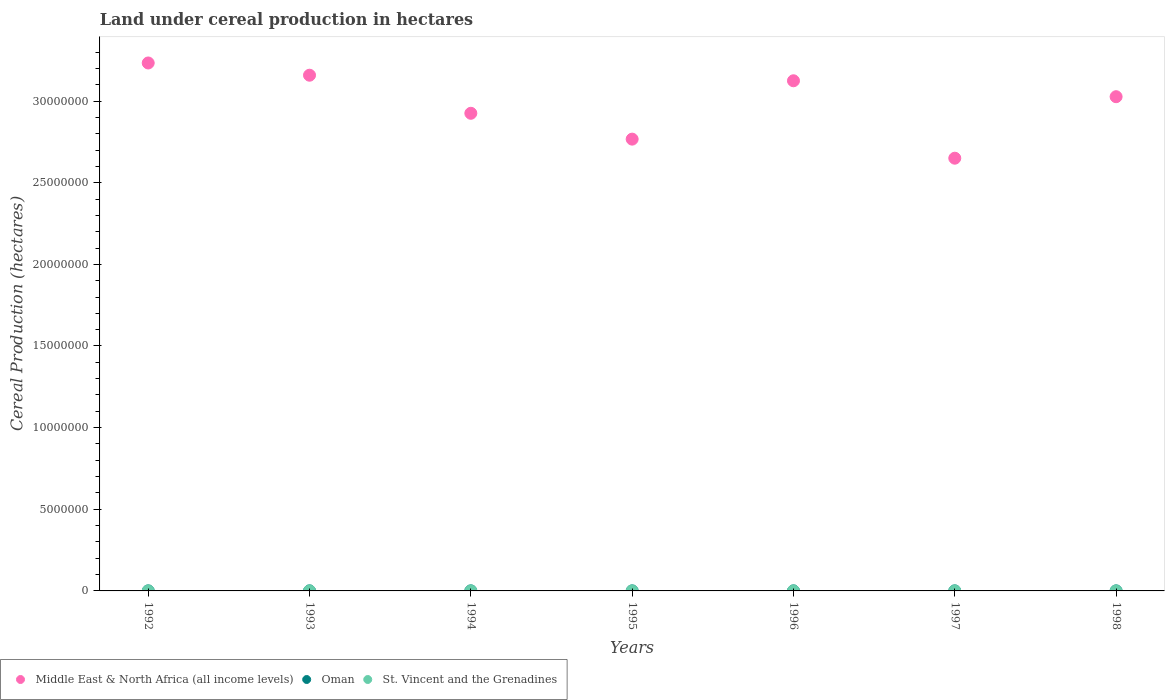Is the number of dotlines equal to the number of legend labels?
Keep it short and to the point. Yes. What is the land under cereal production in Oman in 1992?
Make the answer very short. 2814. Across all years, what is the maximum land under cereal production in Middle East & North Africa (all income levels)?
Provide a short and direct response. 3.23e+07. Across all years, what is the minimum land under cereal production in Middle East & North Africa (all income levels)?
Provide a succinct answer. 2.65e+07. What is the total land under cereal production in Oman in the graph?
Make the answer very short. 2.19e+04. What is the difference between the land under cereal production in Middle East & North Africa (all income levels) in 1993 and that in 1995?
Keep it short and to the point. 3.91e+06. What is the difference between the land under cereal production in Middle East & North Africa (all income levels) in 1998 and the land under cereal production in Oman in 1997?
Make the answer very short. 3.03e+07. What is the average land under cereal production in Oman per year?
Give a very brief answer. 3135.57. In the year 1997, what is the difference between the land under cereal production in St. Vincent and the Grenadines and land under cereal production in Oman?
Make the answer very short. -2891. In how many years, is the land under cereal production in Middle East & North Africa (all income levels) greater than 16000000 hectares?
Offer a terse response. 7. What is the ratio of the land under cereal production in Oman in 1995 to that in 1998?
Make the answer very short. 1.03. Is the land under cereal production in St. Vincent and the Grenadines in 1994 less than that in 1995?
Your answer should be very brief. Yes. Is the difference between the land under cereal production in St. Vincent and the Grenadines in 1992 and 1995 greater than the difference between the land under cereal production in Oman in 1992 and 1995?
Your response must be concise. Yes. What is the difference between the highest and the lowest land under cereal production in Middle East & North Africa (all income levels)?
Provide a succinct answer. 5.83e+06. In how many years, is the land under cereal production in Middle East & North Africa (all income levels) greater than the average land under cereal production in Middle East & North Africa (all income levels) taken over all years?
Your answer should be very brief. 4. Does the land under cereal production in St. Vincent and the Grenadines monotonically increase over the years?
Provide a succinct answer. No. Is the land under cereal production in Oman strictly greater than the land under cereal production in Middle East & North Africa (all income levels) over the years?
Your answer should be very brief. No. Is the land under cereal production in Oman strictly less than the land under cereal production in St. Vincent and the Grenadines over the years?
Your answer should be compact. No. How many dotlines are there?
Your response must be concise. 3. How many years are there in the graph?
Your answer should be compact. 7. Are the values on the major ticks of Y-axis written in scientific E-notation?
Your answer should be compact. No. Does the graph contain any zero values?
Provide a succinct answer. No. What is the title of the graph?
Provide a short and direct response. Land under cereal production in hectares. What is the label or title of the Y-axis?
Give a very brief answer. Cereal Production (hectares). What is the Cereal Production (hectares) of Middle East & North Africa (all income levels) in 1992?
Your response must be concise. 3.23e+07. What is the Cereal Production (hectares) of Oman in 1992?
Your answer should be compact. 2814. What is the Cereal Production (hectares) of St. Vincent and the Grenadines in 1992?
Offer a very short reply. 723. What is the Cereal Production (hectares) in Middle East & North Africa (all income levels) in 1993?
Your answer should be very brief. 3.16e+07. What is the Cereal Production (hectares) of Oman in 1993?
Your answer should be very brief. 3246. What is the Cereal Production (hectares) in St. Vincent and the Grenadines in 1993?
Keep it short and to the point. 761. What is the Cereal Production (hectares) of Middle East & North Africa (all income levels) in 1994?
Offer a terse response. 2.93e+07. What is the Cereal Production (hectares) of Oman in 1994?
Offer a terse response. 3635. What is the Cereal Production (hectares) in St. Vincent and the Grenadines in 1994?
Your answer should be compact. 823. What is the Cereal Production (hectares) in Middle East & North Africa (all income levels) in 1995?
Ensure brevity in your answer.  2.77e+07. What is the Cereal Production (hectares) of Oman in 1995?
Offer a very short reply. 2990. What is the Cereal Production (hectares) of St. Vincent and the Grenadines in 1995?
Keep it short and to the point. 824. What is the Cereal Production (hectares) of Middle East & North Africa (all income levels) in 1996?
Provide a succinct answer. 3.12e+07. What is the Cereal Production (hectares) in Oman in 1996?
Make the answer very short. 3120. What is the Cereal Production (hectares) in St. Vincent and the Grenadines in 1996?
Offer a very short reply. 300. What is the Cereal Production (hectares) in Middle East & North Africa (all income levels) in 1997?
Ensure brevity in your answer.  2.65e+07. What is the Cereal Production (hectares) of Oman in 1997?
Provide a short and direct response. 3250. What is the Cereal Production (hectares) of St. Vincent and the Grenadines in 1997?
Provide a succinct answer. 359. What is the Cereal Production (hectares) in Middle East & North Africa (all income levels) in 1998?
Ensure brevity in your answer.  3.03e+07. What is the Cereal Production (hectares) of Oman in 1998?
Make the answer very short. 2894. What is the Cereal Production (hectares) of St. Vincent and the Grenadines in 1998?
Make the answer very short. 600. Across all years, what is the maximum Cereal Production (hectares) in Middle East & North Africa (all income levels)?
Give a very brief answer. 3.23e+07. Across all years, what is the maximum Cereal Production (hectares) of Oman?
Your answer should be very brief. 3635. Across all years, what is the maximum Cereal Production (hectares) of St. Vincent and the Grenadines?
Your answer should be very brief. 824. Across all years, what is the minimum Cereal Production (hectares) in Middle East & North Africa (all income levels)?
Your answer should be very brief. 2.65e+07. Across all years, what is the minimum Cereal Production (hectares) of Oman?
Offer a very short reply. 2814. Across all years, what is the minimum Cereal Production (hectares) in St. Vincent and the Grenadines?
Offer a terse response. 300. What is the total Cereal Production (hectares) in Middle East & North Africa (all income levels) in the graph?
Offer a very short reply. 2.09e+08. What is the total Cereal Production (hectares) of Oman in the graph?
Provide a succinct answer. 2.19e+04. What is the total Cereal Production (hectares) of St. Vincent and the Grenadines in the graph?
Provide a succinct answer. 4390. What is the difference between the Cereal Production (hectares) in Middle East & North Africa (all income levels) in 1992 and that in 1993?
Your answer should be very brief. 7.50e+05. What is the difference between the Cereal Production (hectares) in Oman in 1992 and that in 1993?
Give a very brief answer. -432. What is the difference between the Cereal Production (hectares) of St. Vincent and the Grenadines in 1992 and that in 1993?
Keep it short and to the point. -38. What is the difference between the Cereal Production (hectares) in Middle East & North Africa (all income levels) in 1992 and that in 1994?
Your response must be concise. 3.08e+06. What is the difference between the Cereal Production (hectares) in Oman in 1992 and that in 1994?
Ensure brevity in your answer.  -821. What is the difference between the Cereal Production (hectares) of St. Vincent and the Grenadines in 1992 and that in 1994?
Keep it short and to the point. -100. What is the difference between the Cereal Production (hectares) in Middle East & North Africa (all income levels) in 1992 and that in 1995?
Ensure brevity in your answer.  4.66e+06. What is the difference between the Cereal Production (hectares) of Oman in 1992 and that in 1995?
Offer a very short reply. -176. What is the difference between the Cereal Production (hectares) in St. Vincent and the Grenadines in 1992 and that in 1995?
Offer a terse response. -101. What is the difference between the Cereal Production (hectares) in Middle East & North Africa (all income levels) in 1992 and that in 1996?
Keep it short and to the point. 1.09e+06. What is the difference between the Cereal Production (hectares) of Oman in 1992 and that in 1996?
Make the answer very short. -306. What is the difference between the Cereal Production (hectares) of St. Vincent and the Grenadines in 1992 and that in 1996?
Your answer should be compact. 423. What is the difference between the Cereal Production (hectares) of Middle East & North Africa (all income levels) in 1992 and that in 1997?
Your answer should be compact. 5.83e+06. What is the difference between the Cereal Production (hectares) in Oman in 1992 and that in 1997?
Ensure brevity in your answer.  -436. What is the difference between the Cereal Production (hectares) of St. Vincent and the Grenadines in 1992 and that in 1997?
Provide a succinct answer. 364. What is the difference between the Cereal Production (hectares) in Middle East & North Africa (all income levels) in 1992 and that in 1998?
Provide a succinct answer. 2.07e+06. What is the difference between the Cereal Production (hectares) of Oman in 1992 and that in 1998?
Make the answer very short. -80. What is the difference between the Cereal Production (hectares) in St. Vincent and the Grenadines in 1992 and that in 1998?
Keep it short and to the point. 123. What is the difference between the Cereal Production (hectares) in Middle East & North Africa (all income levels) in 1993 and that in 1994?
Ensure brevity in your answer.  2.33e+06. What is the difference between the Cereal Production (hectares) in Oman in 1993 and that in 1994?
Provide a short and direct response. -389. What is the difference between the Cereal Production (hectares) of St. Vincent and the Grenadines in 1993 and that in 1994?
Provide a succinct answer. -62. What is the difference between the Cereal Production (hectares) in Middle East & North Africa (all income levels) in 1993 and that in 1995?
Your response must be concise. 3.91e+06. What is the difference between the Cereal Production (hectares) in Oman in 1993 and that in 1995?
Keep it short and to the point. 256. What is the difference between the Cereal Production (hectares) of St. Vincent and the Grenadines in 1993 and that in 1995?
Provide a short and direct response. -63. What is the difference between the Cereal Production (hectares) of Middle East & North Africa (all income levels) in 1993 and that in 1996?
Your response must be concise. 3.41e+05. What is the difference between the Cereal Production (hectares) in Oman in 1993 and that in 1996?
Provide a succinct answer. 126. What is the difference between the Cereal Production (hectares) of St. Vincent and the Grenadines in 1993 and that in 1996?
Keep it short and to the point. 461. What is the difference between the Cereal Production (hectares) of Middle East & North Africa (all income levels) in 1993 and that in 1997?
Your response must be concise. 5.08e+06. What is the difference between the Cereal Production (hectares) of St. Vincent and the Grenadines in 1993 and that in 1997?
Provide a succinct answer. 402. What is the difference between the Cereal Production (hectares) in Middle East & North Africa (all income levels) in 1993 and that in 1998?
Your answer should be very brief. 1.32e+06. What is the difference between the Cereal Production (hectares) in Oman in 1993 and that in 1998?
Offer a very short reply. 352. What is the difference between the Cereal Production (hectares) in St. Vincent and the Grenadines in 1993 and that in 1998?
Give a very brief answer. 161. What is the difference between the Cereal Production (hectares) in Middle East & North Africa (all income levels) in 1994 and that in 1995?
Your answer should be compact. 1.58e+06. What is the difference between the Cereal Production (hectares) in Oman in 1994 and that in 1995?
Offer a very short reply. 645. What is the difference between the Cereal Production (hectares) of St. Vincent and the Grenadines in 1994 and that in 1995?
Give a very brief answer. -1. What is the difference between the Cereal Production (hectares) in Middle East & North Africa (all income levels) in 1994 and that in 1996?
Give a very brief answer. -1.99e+06. What is the difference between the Cereal Production (hectares) of Oman in 1994 and that in 1996?
Your answer should be very brief. 515. What is the difference between the Cereal Production (hectares) of St. Vincent and the Grenadines in 1994 and that in 1996?
Your response must be concise. 523. What is the difference between the Cereal Production (hectares) in Middle East & North Africa (all income levels) in 1994 and that in 1997?
Your answer should be compact. 2.75e+06. What is the difference between the Cereal Production (hectares) in Oman in 1994 and that in 1997?
Provide a succinct answer. 385. What is the difference between the Cereal Production (hectares) in St. Vincent and the Grenadines in 1994 and that in 1997?
Your response must be concise. 464. What is the difference between the Cereal Production (hectares) in Middle East & North Africa (all income levels) in 1994 and that in 1998?
Make the answer very short. -1.02e+06. What is the difference between the Cereal Production (hectares) in Oman in 1994 and that in 1998?
Offer a terse response. 741. What is the difference between the Cereal Production (hectares) of St. Vincent and the Grenadines in 1994 and that in 1998?
Ensure brevity in your answer.  223. What is the difference between the Cereal Production (hectares) in Middle East & North Africa (all income levels) in 1995 and that in 1996?
Your response must be concise. -3.57e+06. What is the difference between the Cereal Production (hectares) of Oman in 1995 and that in 1996?
Offer a terse response. -130. What is the difference between the Cereal Production (hectares) of St. Vincent and the Grenadines in 1995 and that in 1996?
Keep it short and to the point. 524. What is the difference between the Cereal Production (hectares) of Middle East & North Africa (all income levels) in 1995 and that in 1997?
Your response must be concise. 1.17e+06. What is the difference between the Cereal Production (hectares) of Oman in 1995 and that in 1997?
Provide a succinct answer. -260. What is the difference between the Cereal Production (hectares) in St. Vincent and the Grenadines in 1995 and that in 1997?
Offer a very short reply. 465. What is the difference between the Cereal Production (hectares) in Middle East & North Africa (all income levels) in 1995 and that in 1998?
Provide a succinct answer. -2.60e+06. What is the difference between the Cereal Production (hectares) in Oman in 1995 and that in 1998?
Give a very brief answer. 96. What is the difference between the Cereal Production (hectares) in St. Vincent and the Grenadines in 1995 and that in 1998?
Offer a terse response. 224. What is the difference between the Cereal Production (hectares) of Middle East & North Africa (all income levels) in 1996 and that in 1997?
Ensure brevity in your answer.  4.74e+06. What is the difference between the Cereal Production (hectares) in Oman in 1996 and that in 1997?
Ensure brevity in your answer.  -130. What is the difference between the Cereal Production (hectares) in St. Vincent and the Grenadines in 1996 and that in 1997?
Make the answer very short. -59. What is the difference between the Cereal Production (hectares) of Middle East & North Africa (all income levels) in 1996 and that in 1998?
Offer a very short reply. 9.75e+05. What is the difference between the Cereal Production (hectares) of Oman in 1996 and that in 1998?
Your response must be concise. 226. What is the difference between the Cereal Production (hectares) in St. Vincent and the Grenadines in 1996 and that in 1998?
Provide a short and direct response. -300. What is the difference between the Cereal Production (hectares) of Middle East & North Africa (all income levels) in 1997 and that in 1998?
Provide a succinct answer. -3.77e+06. What is the difference between the Cereal Production (hectares) of Oman in 1997 and that in 1998?
Keep it short and to the point. 356. What is the difference between the Cereal Production (hectares) in St. Vincent and the Grenadines in 1997 and that in 1998?
Make the answer very short. -241. What is the difference between the Cereal Production (hectares) of Middle East & North Africa (all income levels) in 1992 and the Cereal Production (hectares) of Oman in 1993?
Offer a very short reply. 3.23e+07. What is the difference between the Cereal Production (hectares) in Middle East & North Africa (all income levels) in 1992 and the Cereal Production (hectares) in St. Vincent and the Grenadines in 1993?
Your answer should be very brief. 3.23e+07. What is the difference between the Cereal Production (hectares) of Oman in 1992 and the Cereal Production (hectares) of St. Vincent and the Grenadines in 1993?
Ensure brevity in your answer.  2053. What is the difference between the Cereal Production (hectares) of Middle East & North Africa (all income levels) in 1992 and the Cereal Production (hectares) of Oman in 1994?
Ensure brevity in your answer.  3.23e+07. What is the difference between the Cereal Production (hectares) of Middle East & North Africa (all income levels) in 1992 and the Cereal Production (hectares) of St. Vincent and the Grenadines in 1994?
Offer a terse response. 3.23e+07. What is the difference between the Cereal Production (hectares) in Oman in 1992 and the Cereal Production (hectares) in St. Vincent and the Grenadines in 1994?
Provide a short and direct response. 1991. What is the difference between the Cereal Production (hectares) in Middle East & North Africa (all income levels) in 1992 and the Cereal Production (hectares) in Oman in 1995?
Your answer should be compact. 3.23e+07. What is the difference between the Cereal Production (hectares) in Middle East & North Africa (all income levels) in 1992 and the Cereal Production (hectares) in St. Vincent and the Grenadines in 1995?
Provide a short and direct response. 3.23e+07. What is the difference between the Cereal Production (hectares) in Oman in 1992 and the Cereal Production (hectares) in St. Vincent and the Grenadines in 1995?
Give a very brief answer. 1990. What is the difference between the Cereal Production (hectares) of Middle East & North Africa (all income levels) in 1992 and the Cereal Production (hectares) of Oman in 1996?
Give a very brief answer. 3.23e+07. What is the difference between the Cereal Production (hectares) of Middle East & North Africa (all income levels) in 1992 and the Cereal Production (hectares) of St. Vincent and the Grenadines in 1996?
Offer a terse response. 3.23e+07. What is the difference between the Cereal Production (hectares) of Oman in 1992 and the Cereal Production (hectares) of St. Vincent and the Grenadines in 1996?
Ensure brevity in your answer.  2514. What is the difference between the Cereal Production (hectares) in Middle East & North Africa (all income levels) in 1992 and the Cereal Production (hectares) in Oman in 1997?
Offer a very short reply. 3.23e+07. What is the difference between the Cereal Production (hectares) in Middle East & North Africa (all income levels) in 1992 and the Cereal Production (hectares) in St. Vincent and the Grenadines in 1997?
Provide a short and direct response. 3.23e+07. What is the difference between the Cereal Production (hectares) in Oman in 1992 and the Cereal Production (hectares) in St. Vincent and the Grenadines in 1997?
Your answer should be compact. 2455. What is the difference between the Cereal Production (hectares) in Middle East & North Africa (all income levels) in 1992 and the Cereal Production (hectares) in Oman in 1998?
Provide a succinct answer. 3.23e+07. What is the difference between the Cereal Production (hectares) of Middle East & North Africa (all income levels) in 1992 and the Cereal Production (hectares) of St. Vincent and the Grenadines in 1998?
Keep it short and to the point. 3.23e+07. What is the difference between the Cereal Production (hectares) of Oman in 1992 and the Cereal Production (hectares) of St. Vincent and the Grenadines in 1998?
Offer a very short reply. 2214. What is the difference between the Cereal Production (hectares) in Middle East & North Africa (all income levels) in 1993 and the Cereal Production (hectares) in Oman in 1994?
Offer a terse response. 3.16e+07. What is the difference between the Cereal Production (hectares) in Middle East & North Africa (all income levels) in 1993 and the Cereal Production (hectares) in St. Vincent and the Grenadines in 1994?
Offer a terse response. 3.16e+07. What is the difference between the Cereal Production (hectares) of Oman in 1993 and the Cereal Production (hectares) of St. Vincent and the Grenadines in 1994?
Your answer should be compact. 2423. What is the difference between the Cereal Production (hectares) of Middle East & North Africa (all income levels) in 1993 and the Cereal Production (hectares) of Oman in 1995?
Provide a short and direct response. 3.16e+07. What is the difference between the Cereal Production (hectares) in Middle East & North Africa (all income levels) in 1993 and the Cereal Production (hectares) in St. Vincent and the Grenadines in 1995?
Offer a terse response. 3.16e+07. What is the difference between the Cereal Production (hectares) of Oman in 1993 and the Cereal Production (hectares) of St. Vincent and the Grenadines in 1995?
Provide a succinct answer. 2422. What is the difference between the Cereal Production (hectares) of Middle East & North Africa (all income levels) in 1993 and the Cereal Production (hectares) of Oman in 1996?
Ensure brevity in your answer.  3.16e+07. What is the difference between the Cereal Production (hectares) of Middle East & North Africa (all income levels) in 1993 and the Cereal Production (hectares) of St. Vincent and the Grenadines in 1996?
Your answer should be very brief. 3.16e+07. What is the difference between the Cereal Production (hectares) of Oman in 1993 and the Cereal Production (hectares) of St. Vincent and the Grenadines in 1996?
Provide a succinct answer. 2946. What is the difference between the Cereal Production (hectares) of Middle East & North Africa (all income levels) in 1993 and the Cereal Production (hectares) of Oman in 1997?
Give a very brief answer. 3.16e+07. What is the difference between the Cereal Production (hectares) in Middle East & North Africa (all income levels) in 1993 and the Cereal Production (hectares) in St. Vincent and the Grenadines in 1997?
Offer a terse response. 3.16e+07. What is the difference between the Cereal Production (hectares) of Oman in 1993 and the Cereal Production (hectares) of St. Vincent and the Grenadines in 1997?
Provide a short and direct response. 2887. What is the difference between the Cereal Production (hectares) in Middle East & North Africa (all income levels) in 1993 and the Cereal Production (hectares) in Oman in 1998?
Make the answer very short. 3.16e+07. What is the difference between the Cereal Production (hectares) of Middle East & North Africa (all income levels) in 1993 and the Cereal Production (hectares) of St. Vincent and the Grenadines in 1998?
Make the answer very short. 3.16e+07. What is the difference between the Cereal Production (hectares) of Oman in 1993 and the Cereal Production (hectares) of St. Vincent and the Grenadines in 1998?
Keep it short and to the point. 2646. What is the difference between the Cereal Production (hectares) of Middle East & North Africa (all income levels) in 1994 and the Cereal Production (hectares) of Oman in 1995?
Your answer should be compact. 2.92e+07. What is the difference between the Cereal Production (hectares) in Middle East & North Africa (all income levels) in 1994 and the Cereal Production (hectares) in St. Vincent and the Grenadines in 1995?
Offer a very short reply. 2.93e+07. What is the difference between the Cereal Production (hectares) in Oman in 1994 and the Cereal Production (hectares) in St. Vincent and the Grenadines in 1995?
Offer a terse response. 2811. What is the difference between the Cereal Production (hectares) of Middle East & North Africa (all income levels) in 1994 and the Cereal Production (hectares) of Oman in 1996?
Make the answer very short. 2.92e+07. What is the difference between the Cereal Production (hectares) in Middle East & North Africa (all income levels) in 1994 and the Cereal Production (hectares) in St. Vincent and the Grenadines in 1996?
Give a very brief answer. 2.93e+07. What is the difference between the Cereal Production (hectares) in Oman in 1994 and the Cereal Production (hectares) in St. Vincent and the Grenadines in 1996?
Your answer should be very brief. 3335. What is the difference between the Cereal Production (hectares) of Middle East & North Africa (all income levels) in 1994 and the Cereal Production (hectares) of Oman in 1997?
Make the answer very short. 2.92e+07. What is the difference between the Cereal Production (hectares) in Middle East & North Africa (all income levels) in 1994 and the Cereal Production (hectares) in St. Vincent and the Grenadines in 1997?
Your answer should be very brief. 2.93e+07. What is the difference between the Cereal Production (hectares) in Oman in 1994 and the Cereal Production (hectares) in St. Vincent and the Grenadines in 1997?
Provide a short and direct response. 3276. What is the difference between the Cereal Production (hectares) of Middle East & North Africa (all income levels) in 1994 and the Cereal Production (hectares) of Oman in 1998?
Offer a very short reply. 2.92e+07. What is the difference between the Cereal Production (hectares) of Middle East & North Africa (all income levels) in 1994 and the Cereal Production (hectares) of St. Vincent and the Grenadines in 1998?
Provide a succinct answer. 2.93e+07. What is the difference between the Cereal Production (hectares) of Oman in 1994 and the Cereal Production (hectares) of St. Vincent and the Grenadines in 1998?
Provide a succinct answer. 3035. What is the difference between the Cereal Production (hectares) in Middle East & North Africa (all income levels) in 1995 and the Cereal Production (hectares) in Oman in 1996?
Provide a succinct answer. 2.77e+07. What is the difference between the Cereal Production (hectares) of Middle East & North Africa (all income levels) in 1995 and the Cereal Production (hectares) of St. Vincent and the Grenadines in 1996?
Keep it short and to the point. 2.77e+07. What is the difference between the Cereal Production (hectares) in Oman in 1995 and the Cereal Production (hectares) in St. Vincent and the Grenadines in 1996?
Your response must be concise. 2690. What is the difference between the Cereal Production (hectares) in Middle East & North Africa (all income levels) in 1995 and the Cereal Production (hectares) in Oman in 1997?
Your answer should be compact. 2.77e+07. What is the difference between the Cereal Production (hectares) in Middle East & North Africa (all income levels) in 1995 and the Cereal Production (hectares) in St. Vincent and the Grenadines in 1997?
Make the answer very short. 2.77e+07. What is the difference between the Cereal Production (hectares) in Oman in 1995 and the Cereal Production (hectares) in St. Vincent and the Grenadines in 1997?
Your answer should be compact. 2631. What is the difference between the Cereal Production (hectares) in Middle East & North Africa (all income levels) in 1995 and the Cereal Production (hectares) in Oman in 1998?
Your response must be concise. 2.77e+07. What is the difference between the Cereal Production (hectares) of Middle East & North Africa (all income levels) in 1995 and the Cereal Production (hectares) of St. Vincent and the Grenadines in 1998?
Your answer should be compact. 2.77e+07. What is the difference between the Cereal Production (hectares) in Oman in 1995 and the Cereal Production (hectares) in St. Vincent and the Grenadines in 1998?
Make the answer very short. 2390. What is the difference between the Cereal Production (hectares) of Middle East & North Africa (all income levels) in 1996 and the Cereal Production (hectares) of Oman in 1997?
Your answer should be compact. 3.12e+07. What is the difference between the Cereal Production (hectares) in Middle East & North Africa (all income levels) in 1996 and the Cereal Production (hectares) in St. Vincent and the Grenadines in 1997?
Your answer should be very brief. 3.12e+07. What is the difference between the Cereal Production (hectares) in Oman in 1996 and the Cereal Production (hectares) in St. Vincent and the Grenadines in 1997?
Provide a short and direct response. 2761. What is the difference between the Cereal Production (hectares) in Middle East & North Africa (all income levels) in 1996 and the Cereal Production (hectares) in Oman in 1998?
Offer a very short reply. 3.12e+07. What is the difference between the Cereal Production (hectares) of Middle East & North Africa (all income levels) in 1996 and the Cereal Production (hectares) of St. Vincent and the Grenadines in 1998?
Offer a terse response. 3.12e+07. What is the difference between the Cereal Production (hectares) of Oman in 1996 and the Cereal Production (hectares) of St. Vincent and the Grenadines in 1998?
Give a very brief answer. 2520. What is the difference between the Cereal Production (hectares) of Middle East & North Africa (all income levels) in 1997 and the Cereal Production (hectares) of Oman in 1998?
Give a very brief answer. 2.65e+07. What is the difference between the Cereal Production (hectares) in Middle East & North Africa (all income levels) in 1997 and the Cereal Production (hectares) in St. Vincent and the Grenadines in 1998?
Keep it short and to the point. 2.65e+07. What is the difference between the Cereal Production (hectares) in Oman in 1997 and the Cereal Production (hectares) in St. Vincent and the Grenadines in 1998?
Provide a short and direct response. 2650. What is the average Cereal Production (hectares) in Middle East & North Africa (all income levels) per year?
Provide a succinct answer. 2.98e+07. What is the average Cereal Production (hectares) in Oman per year?
Provide a succinct answer. 3135.57. What is the average Cereal Production (hectares) in St. Vincent and the Grenadines per year?
Offer a very short reply. 627.14. In the year 1992, what is the difference between the Cereal Production (hectares) of Middle East & North Africa (all income levels) and Cereal Production (hectares) of Oman?
Ensure brevity in your answer.  3.23e+07. In the year 1992, what is the difference between the Cereal Production (hectares) of Middle East & North Africa (all income levels) and Cereal Production (hectares) of St. Vincent and the Grenadines?
Offer a terse response. 3.23e+07. In the year 1992, what is the difference between the Cereal Production (hectares) in Oman and Cereal Production (hectares) in St. Vincent and the Grenadines?
Your answer should be very brief. 2091. In the year 1993, what is the difference between the Cereal Production (hectares) of Middle East & North Africa (all income levels) and Cereal Production (hectares) of Oman?
Your response must be concise. 3.16e+07. In the year 1993, what is the difference between the Cereal Production (hectares) in Middle East & North Africa (all income levels) and Cereal Production (hectares) in St. Vincent and the Grenadines?
Provide a succinct answer. 3.16e+07. In the year 1993, what is the difference between the Cereal Production (hectares) of Oman and Cereal Production (hectares) of St. Vincent and the Grenadines?
Your response must be concise. 2485. In the year 1994, what is the difference between the Cereal Production (hectares) of Middle East & North Africa (all income levels) and Cereal Production (hectares) of Oman?
Your response must be concise. 2.92e+07. In the year 1994, what is the difference between the Cereal Production (hectares) in Middle East & North Africa (all income levels) and Cereal Production (hectares) in St. Vincent and the Grenadines?
Your answer should be compact. 2.93e+07. In the year 1994, what is the difference between the Cereal Production (hectares) of Oman and Cereal Production (hectares) of St. Vincent and the Grenadines?
Ensure brevity in your answer.  2812. In the year 1995, what is the difference between the Cereal Production (hectares) in Middle East & North Africa (all income levels) and Cereal Production (hectares) in Oman?
Give a very brief answer. 2.77e+07. In the year 1995, what is the difference between the Cereal Production (hectares) of Middle East & North Africa (all income levels) and Cereal Production (hectares) of St. Vincent and the Grenadines?
Give a very brief answer. 2.77e+07. In the year 1995, what is the difference between the Cereal Production (hectares) of Oman and Cereal Production (hectares) of St. Vincent and the Grenadines?
Your response must be concise. 2166. In the year 1996, what is the difference between the Cereal Production (hectares) in Middle East & North Africa (all income levels) and Cereal Production (hectares) in Oman?
Keep it short and to the point. 3.12e+07. In the year 1996, what is the difference between the Cereal Production (hectares) of Middle East & North Africa (all income levels) and Cereal Production (hectares) of St. Vincent and the Grenadines?
Ensure brevity in your answer.  3.12e+07. In the year 1996, what is the difference between the Cereal Production (hectares) in Oman and Cereal Production (hectares) in St. Vincent and the Grenadines?
Give a very brief answer. 2820. In the year 1997, what is the difference between the Cereal Production (hectares) of Middle East & North Africa (all income levels) and Cereal Production (hectares) of Oman?
Offer a terse response. 2.65e+07. In the year 1997, what is the difference between the Cereal Production (hectares) of Middle East & North Africa (all income levels) and Cereal Production (hectares) of St. Vincent and the Grenadines?
Give a very brief answer. 2.65e+07. In the year 1997, what is the difference between the Cereal Production (hectares) in Oman and Cereal Production (hectares) in St. Vincent and the Grenadines?
Make the answer very short. 2891. In the year 1998, what is the difference between the Cereal Production (hectares) of Middle East & North Africa (all income levels) and Cereal Production (hectares) of Oman?
Your response must be concise. 3.03e+07. In the year 1998, what is the difference between the Cereal Production (hectares) of Middle East & North Africa (all income levels) and Cereal Production (hectares) of St. Vincent and the Grenadines?
Keep it short and to the point. 3.03e+07. In the year 1998, what is the difference between the Cereal Production (hectares) of Oman and Cereal Production (hectares) of St. Vincent and the Grenadines?
Keep it short and to the point. 2294. What is the ratio of the Cereal Production (hectares) in Middle East & North Africa (all income levels) in 1992 to that in 1993?
Offer a very short reply. 1.02. What is the ratio of the Cereal Production (hectares) of Oman in 1992 to that in 1993?
Your answer should be very brief. 0.87. What is the ratio of the Cereal Production (hectares) in St. Vincent and the Grenadines in 1992 to that in 1993?
Offer a very short reply. 0.95. What is the ratio of the Cereal Production (hectares) of Middle East & North Africa (all income levels) in 1992 to that in 1994?
Keep it short and to the point. 1.11. What is the ratio of the Cereal Production (hectares) of Oman in 1992 to that in 1994?
Provide a short and direct response. 0.77. What is the ratio of the Cereal Production (hectares) in St. Vincent and the Grenadines in 1992 to that in 1994?
Provide a short and direct response. 0.88. What is the ratio of the Cereal Production (hectares) in Middle East & North Africa (all income levels) in 1992 to that in 1995?
Your answer should be compact. 1.17. What is the ratio of the Cereal Production (hectares) of Oman in 1992 to that in 1995?
Offer a very short reply. 0.94. What is the ratio of the Cereal Production (hectares) in St. Vincent and the Grenadines in 1992 to that in 1995?
Offer a terse response. 0.88. What is the ratio of the Cereal Production (hectares) in Middle East & North Africa (all income levels) in 1992 to that in 1996?
Keep it short and to the point. 1.03. What is the ratio of the Cereal Production (hectares) of Oman in 1992 to that in 1996?
Offer a terse response. 0.9. What is the ratio of the Cereal Production (hectares) of St. Vincent and the Grenadines in 1992 to that in 1996?
Keep it short and to the point. 2.41. What is the ratio of the Cereal Production (hectares) of Middle East & North Africa (all income levels) in 1992 to that in 1997?
Your answer should be compact. 1.22. What is the ratio of the Cereal Production (hectares) in Oman in 1992 to that in 1997?
Keep it short and to the point. 0.87. What is the ratio of the Cereal Production (hectares) of St. Vincent and the Grenadines in 1992 to that in 1997?
Your answer should be compact. 2.01. What is the ratio of the Cereal Production (hectares) of Middle East & North Africa (all income levels) in 1992 to that in 1998?
Offer a terse response. 1.07. What is the ratio of the Cereal Production (hectares) of Oman in 1992 to that in 1998?
Your answer should be compact. 0.97. What is the ratio of the Cereal Production (hectares) of St. Vincent and the Grenadines in 1992 to that in 1998?
Offer a very short reply. 1.21. What is the ratio of the Cereal Production (hectares) in Middle East & North Africa (all income levels) in 1993 to that in 1994?
Provide a succinct answer. 1.08. What is the ratio of the Cereal Production (hectares) of Oman in 1993 to that in 1994?
Provide a short and direct response. 0.89. What is the ratio of the Cereal Production (hectares) of St. Vincent and the Grenadines in 1993 to that in 1994?
Give a very brief answer. 0.92. What is the ratio of the Cereal Production (hectares) of Middle East & North Africa (all income levels) in 1993 to that in 1995?
Ensure brevity in your answer.  1.14. What is the ratio of the Cereal Production (hectares) of Oman in 1993 to that in 1995?
Your answer should be very brief. 1.09. What is the ratio of the Cereal Production (hectares) in St. Vincent and the Grenadines in 1993 to that in 1995?
Make the answer very short. 0.92. What is the ratio of the Cereal Production (hectares) in Middle East & North Africa (all income levels) in 1993 to that in 1996?
Make the answer very short. 1.01. What is the ratio of the Cereal Production (hectares) in Oman in 1993 to that in 1996?
Your answer should be compact. 1.04. What is the ratio of the Cereal Production (hectares) of St. Vincent and the Grenadines in 1993 to that in 1996?
Give a very brief answer. 2.54. What is the ratio of the Cereal Production (hectares) in Middle East & North Africa (all income levels) in 1993 to that in 1997?
Keep it short and to the point. 1.19. What is the ratio of the Cereal Production (hectares) in Oman in 1993 to that in 1997?
Your answer should be very brief. 1. What is the ratio of the Cereal Production (hectares) in St. Vincent and the Grenadines in 1993 to that in 1997?
Make the answer very short. 2.12. What is the ratio of the Cereal Production (hectares) in Middle East & North Africa (all income levels) in 1993 to that in 1998?
Your response must be concise. 1.04. What is the ratio of the Cereal Production (hectares) in Oman in 1993 to that in 1998?
Offer a terse response. 1.12. What is the ratio of the Cereal Production (hectares) in St. Vincent and the Grenadines in 1993 to that in 1998?
Offer a terse response. 1.27. What is the ratio of the Cereal Production (hectares) of Middle East & North Africa (all income levels) in 1994 to that in 1995?
Provide a short and direct response. 1.06. What is the ratio of the Cereal Production (hectares) of Oman in 1994 to that in 1995?
Offer a very short reply. 1.22. What is the ratio of the Cereal Production (hectares) in St. Vincent and the Grenadines in 1994 to that in 1995?
Offer a very short reply. 1. What is the ratio of the Cereal Production (hectares) of Middle East & North Africa (all income levels) in 1994 to that in 1996?
Offer a very short reply. 0.94. What is the ratio of the Cereal Production (hectares) of Oman in 1994 to that in 1996?
Your response must be concise. 1.17. What is the ratio of the Cereal Production (hectares) in St. Vincent and the Grenadines in 1994 to that in 1996?
Offer a very short reply. 2.74. What is the ratio of the Cereal Production (hectares) in Middle East & North Africa (all income levels) in 1994 to that in 1997?
Keep it short and to the point. 1.1. What is the ratio of the Cereal Production (hectares) of Oman in 1994 to that in 1997?
Your answer should be compact. 1.12. What is the ratio of the Cereal Production (hectares) of St. Vincent and the Grenadines in 1994 to that in 1997?
Provide a short and direct response. 2.29. What is the ratio of the Cereal Production (hectares) of Middle East & North Africa (all income levels) in 1994 to that in 1998?
Ensure brevity in your answer.  0.97. What is the ratio of the Cereal Production (hectares) in Oman in 1994 to that in 1998?
Keep it short and to the point. 1.26. What is the ratio of the Cereal Production (hectares) of St. Vincent and the Grenadines in 1994 to that in 1998?
Your answer should be very brief. 1.37. What is the ratio of the Cereal Production (hectares) in Middle East & North Africa (all income levels) in 1995 to that in 1996?
Make the answer very short. 0.89. What is the ratio of the Cereal Production (hectares) in Oman in 1995 to that in 1996?
Give a very brief answer. 0.96. What is the ratio of the Cereal Production (hectares) in St. Vincent and the Grenadines in 1995 to that in 1996?
Offer a terse response. 2.75. What is the ratio of the Cereal Production (hectares) in Middle East & North Africa (all income levels) in 1995 to that in 1997?
Your answer should be very brief. 1.04. What is the ratio of the Cereal Production (hectares) of St. Vincent and the Grenadines in 1995 to that in 1997?
Offer a very short reply. 2.3. What is the ratio of the Cereal Production (hectares) in Middle East & North Africa (all income levels) in 1995 to that in 1998?
Provide a succinct answer. 0.91. What is the ratio of the Cereal Production (hectares) in Oman in 1995 to that in 1998?
Provide a short and direct response. 1.03. What is the ratio of the Cereal Production (hectares) of St. Vincent and the Grenadines in 1995 to that in 1998?
Your response must be concise. 1.37. What is the ratio of the Cereal Production (hectares) of Middle East & North Africa (all income levels) in 1996 to that in 1997?
Keep it short and to the point. 1.18. What is the ratio of the Cereal Production (hectares) of St. Vincent and the Grenadines in 1996 to that in 1997?
Ensure brevity in your answer.  0.84. What is the ratio of the Cereal Production (hectares) in Middle East & North Africa (all income levels) in 1996 to that in 1998?
Offer a terse response. 1.03. What is the ratio of the Cereal Production (hectares) of Oman in 1996 to that in 1998?
Offer a terse response. 1.08. What is the ratio of the Cereal Production (hectares) in St. Vincent and the Grenadines in 1996 to that in 1998?
Give a very brief answer. 0.5. What is the ratio of the Cereal Production (hectares) in Middle East & North Africa (all income levels) in 1997 to that in 1998?
Your answer should be very brief. 0.88. What is the ratio of the Cereal Production (hectares) of Oman in 1997 to that in 1998?
Your answer should be very brief. 1.12. What is the ratio of the Cereal Production (hectares) of St. Vincent and the Grenadines in 1997 to that in 1998?
Offer a very short reply. 0.6. What is the difference between the highest and the second highest Cereal Production (hectares) of Middle East & North Africa (all income levels)?
Your answer should be very brief. 7.50e+05. What is the difference between the highest and the second highest Cereal Production (hectares) in Oman?
Offer a terse response. 385. What is the difference between the highest and the second highest Cereal Production (hectares) in St. Vincent and the Grenadines?
Your answer should be very brief. 1. What is the difference between the highest and the lowest Cereal Production (hectares) of Middle East & North Africa (all income levels)?
Provide a short and direct response. 5.83e+06. What is the difference between the highest and the lowest Cereal Production (hectares) in Oman?
Keep it short and to the point. 821. What is the difference between the highest and the lowest Cereal Production (hectares) of St. Vincent and the Grenadines?
Offer a terse response. 524. 